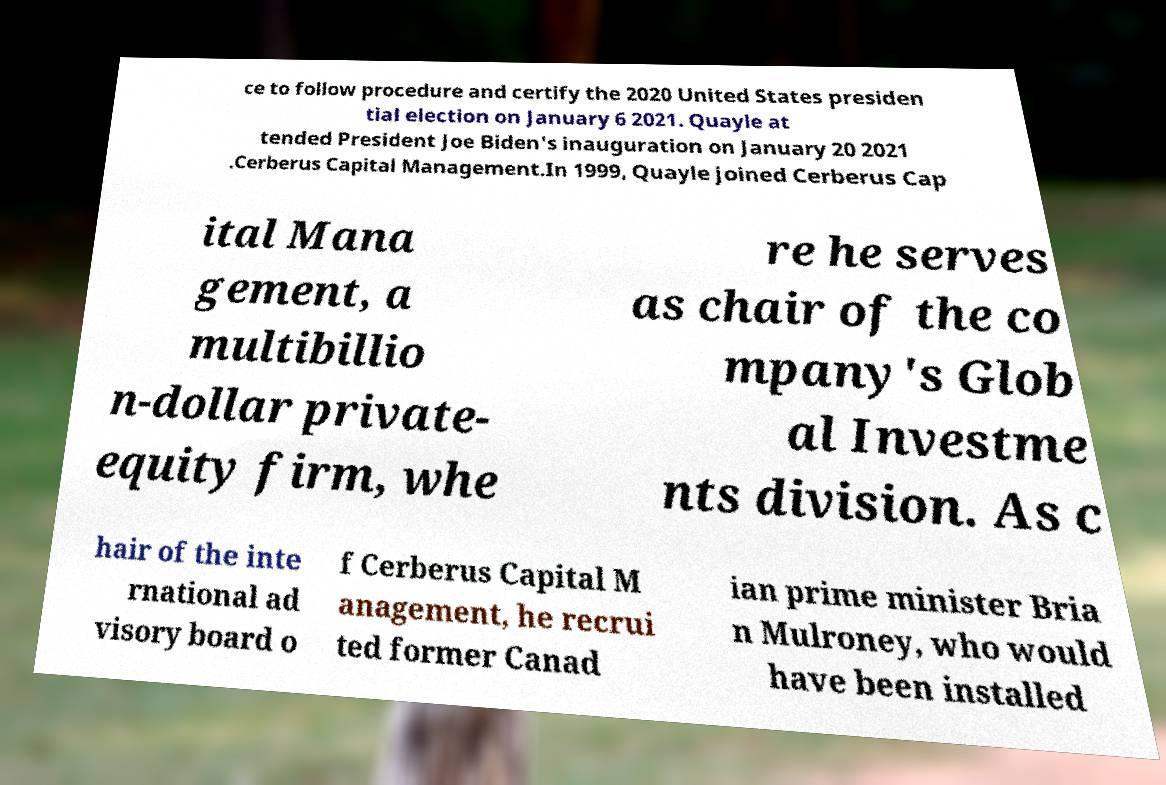Please read and relay the text visible in this image. What does it say? ce to follow procedure and certify the 2020 United States presiden tial election on January 6 2021. Quayle at tended President Joe Biden's inauguration on January 20 2021 .Cerberus Capital Management.In 1999, Quayle joined Cerberus Cap ital Mana gement, a multibillio n-dollar private- equity firm, whe re he serves as chair of the co mpany's Glob al Investme nts division. As c hair of the inte rnational ad visory board o f Cerberus Capital M anagement, he recrui ted former Canad ian prime minister Bria n Mulroney, who would have been installed 